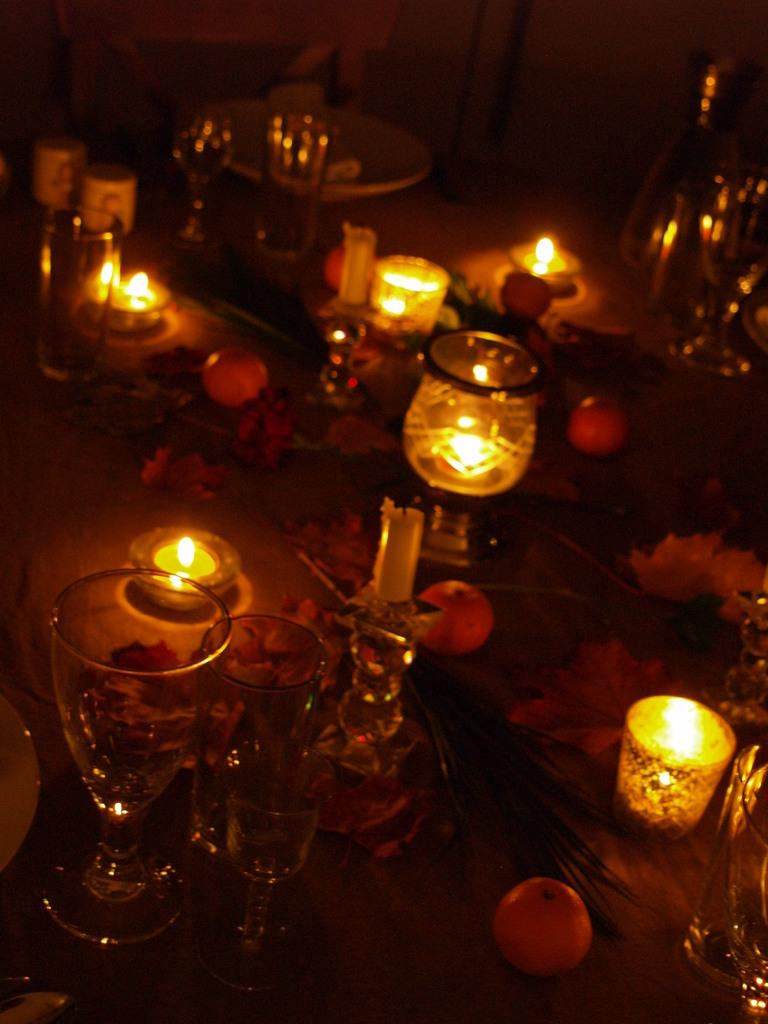What objects are placed on the table in the image? There are glasses and plates on a table in the image. What decorations can be seen on the table? The table is decorated with candles, fruits, and flowers. What type of detail can be seen on the grandfather's shirt in the image? There is no grandfather or shirt present in the image. How many drops of water are visible on the table in the image? There are no drops of water visible on the table in the image. 